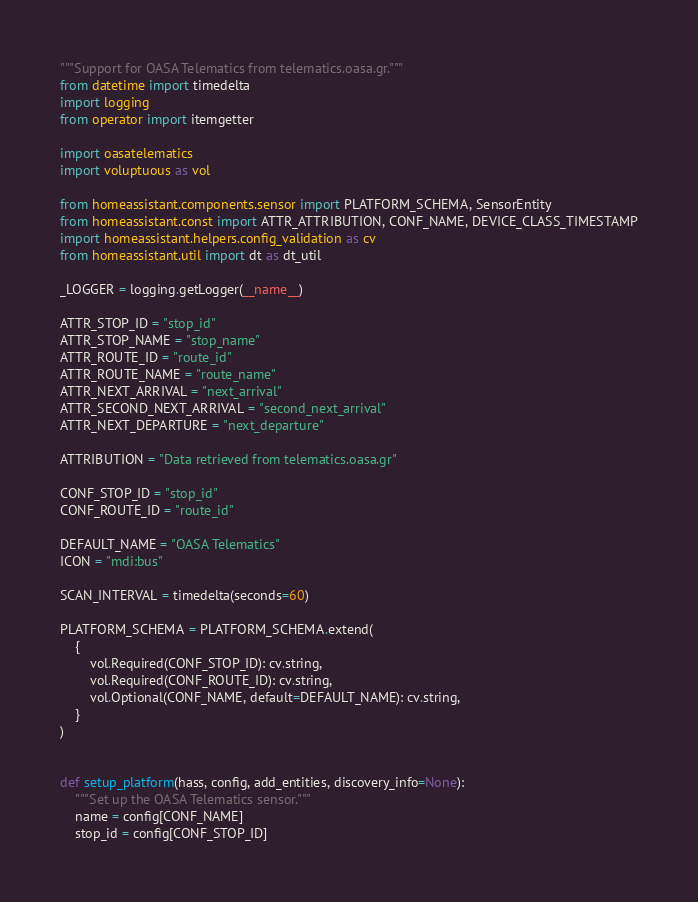Convert code to text. <code><loc_0><loc_0><loc_500><loc_500><_Python_>"""Support for OASA Telematics from telematics.oasa.gr."""
from datetime import timedelta
import logging
from operator import itemgetter

import oasatelematics
import voluptuous as vol

from homeassistant.components.sensor import PLATFORM_SCHEMA, SensorEntity
from homeassistant.const import ATTR_ATTRIBUTION, CONF_NAME, DEVICE_CLASS_TIMESTAMP
import homeassistant.helpers.config_validation as cv
from homeassistant.util import dt as dt_util

_LOGGER = logging.getLogger(__name__)

ATTR_STOP_ID = "stop_id"
ATTR_STOP_NAME = "stop_name"
ATTR_ROUTE_ID = "route_id"
ATTR_ROUTE_NAME = "route_name"
ATTR_NEXT_ARRIVAL = "next_arrival"
ATTR_SECOND_NEXT_ARRIVAL = "second_next_arrival"
ATTR_NEXT_DEPARTURE = "next_departure"

ATTRIBUTION = "Data retrieved from telematics.oasa.gr"

CONF_STOP_ID = "stop_id"
CONF_ROUTE_ID = "route_id"

DEFAULT_NAME = "OASA Telematics"
ICON = "mdi:bus"

SCAN_INTERVAL = timedelta(seconds=60)

PLATFORM_SCHEMA = PLATFORM_SCHEMA.extend(
    {
        vol.Required(CONF_STOP_ID): cv.string,
        vol.Required(CONF_ROUTE_ID): cv.string,
        vol.Optional(CONF_NAME, default=DEFAULT_NAME): cv.string,
    }
)


def setup_platform(hass, config, add_entities, discovery_info=None):
    """Set up the OASA Telematics sensor."""
    name = config[CONF_NAME]
    stop_id = config[CONF_STOP_ID]</code> 